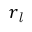Convert formula to latex. <formula><loc_0><loc_0><loc_500><loc_500>r _ { l }</formula> 